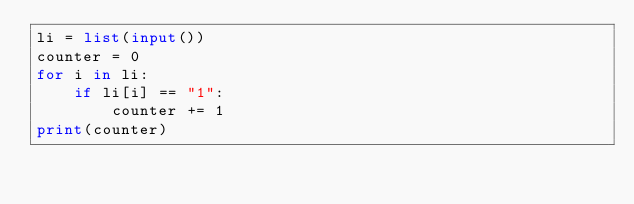Convert code to text. <code><loc_0><loc_0><loc_500><loc_500><_Python_>li = list(input())
counter = 0
for i in li:
    if li[i] == "1":
        counter += 1
print(counter)</code> 